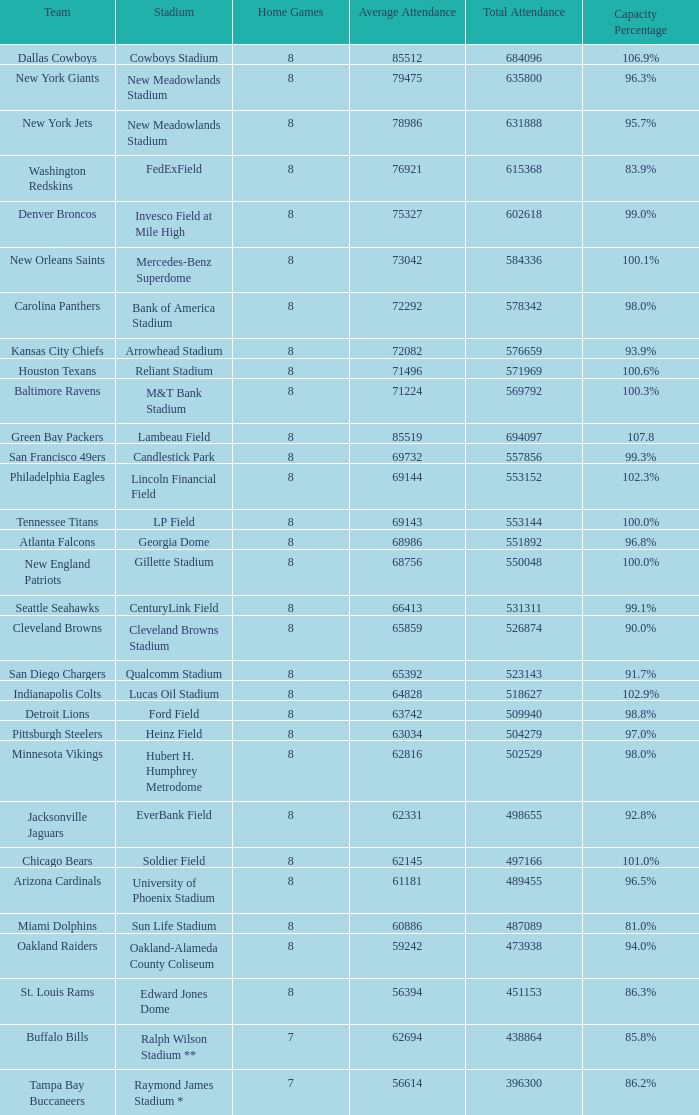At a total attendance of 509,940, what is the capacity percentage? 98.8%. 